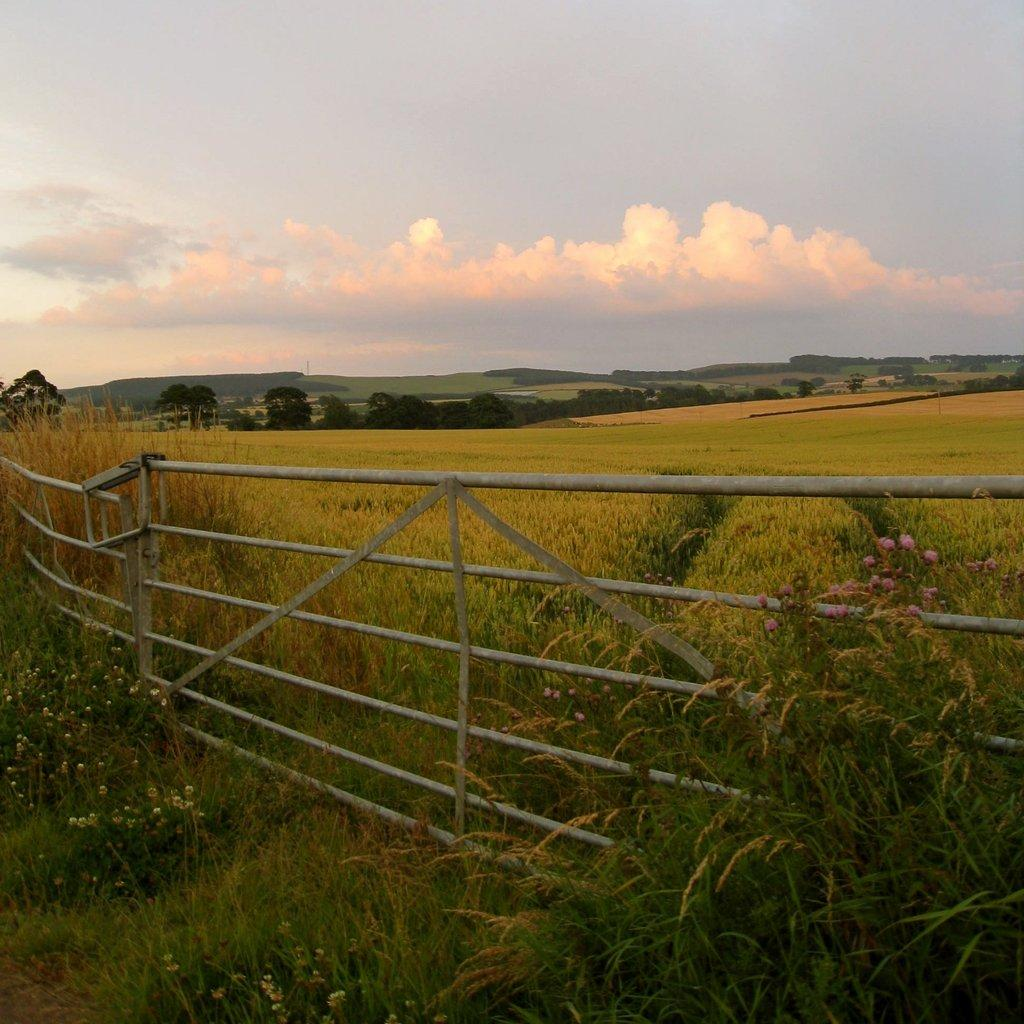What type of living organisms can be seen in the image? Plants can be seen in the image. What is located in the middle of the image? There is fencing in the middle of the image. What is visible at the top of the image? The sky is visible at the top of the image. What type of cushion can be seen in the image? There is no cushion present in the image. Is there a zoo visible in the image? There is no zoo present in the image. 